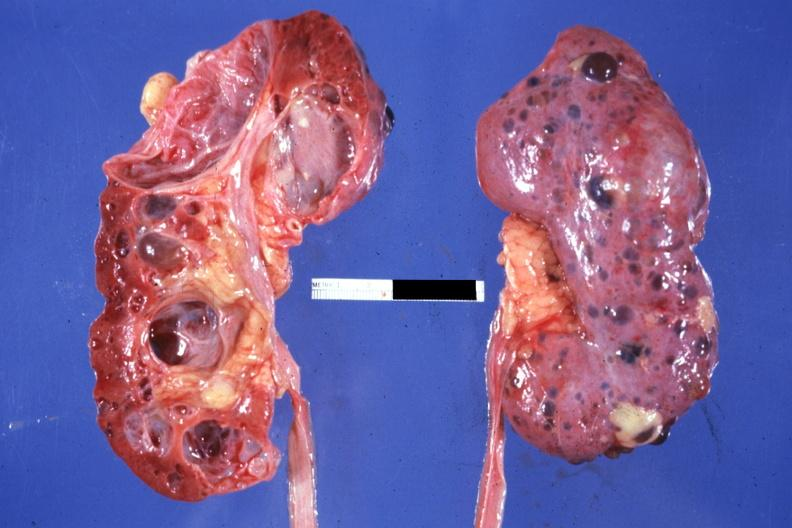s multicystic present?
Answer the question using a single word or phrase. Yes 